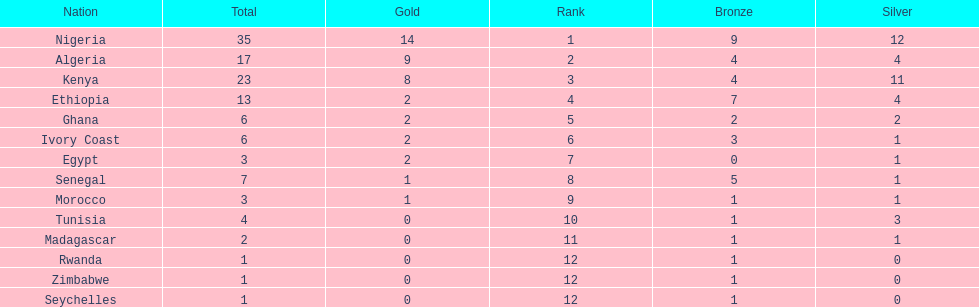How many silver medals did kenya earn? 11. Would you mind parsing the complete table? {'header': ['Nation', 'Total', 'Gold', 'Rank', 'Bronze', 'Silver'], 'rows': [['Nigeria', '35', '14', '1', '9', '12'], ['Algeria', '17', '9', '2', '4', '4'], ['Kenya', '23', '8', '3', '4', '11'], ['Ethiopia', '13', '2', '4', '7', '4'], ['Ghana', '6', '2', '5', '2', '2'], ['Ivory Coast', '6', '2', '6', '3', '1'], ['Egypt', '3', '2', '7', '0', '1'], ['Senegal', '7', '1', '8', '5', '1'], ['Morocco', '3', '1', '9', '1', '1'], ['Tunisia', '4', '0', '10', '1', '3'], ['Madagascar', '2', '0', '11', '1', '1'], ['Rwanda', '1', '0', '12', '1', '0'], ['Zimbabwe', '1', '0', '12', '1', '0'], ['Seychelles', '1', '0', '12', '1', '0']]} 